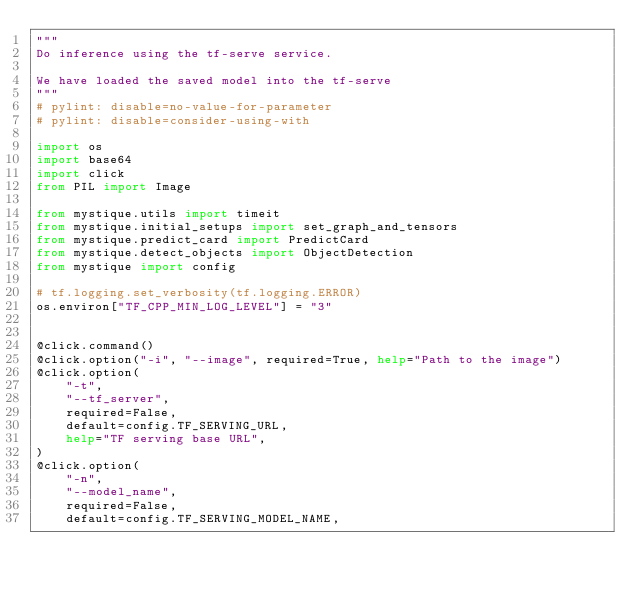Convert code to text. <code><loc_0><loc_0><loc_500><loc_500><_Python_>"""
Do inference using the tf-serve service.

We have loaded the saved model into the tf-serve
"""
# pylint: disable=no-value-for-parameter
# pylint: disable=consider-using-with

import os
import base64
import click
from PIL import Image

from mystique.utils import timeit
from mystique.initial_setups import set_graph_and_tensors
from mystique.predict_card import PredictCard
from mystique.detect_objects import ObjectDetection
from mystique import config

# tf.logging.set_verbosity(tf.logging.ERROR)
os.environ["TF_CPP_MIN_LOG_LEVEL"] = "3"


@click.command()
@click.option("-i", "--image", required=True, help="Path to the image")
@click.option(
    "-t",
    "--tf_server",
    required=False,
    default=config.TF_SERVING_URL,
    help="TF serving base URL",
)
@click.option(
    "-n",
    "--model_name",
    required=False,
    default=config.TF_SERVING_MODEL_NAME,</code> 